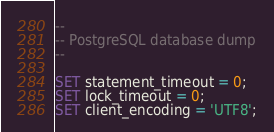<code> <loc_0><loc_0><loc_500><loc_500><_SQL_>--
-- PostgreSQL database dump
--

SET statement_timeout = 0;
SET lock_timeout = 0;
SET client_encoding = 'UTF8';</code> 